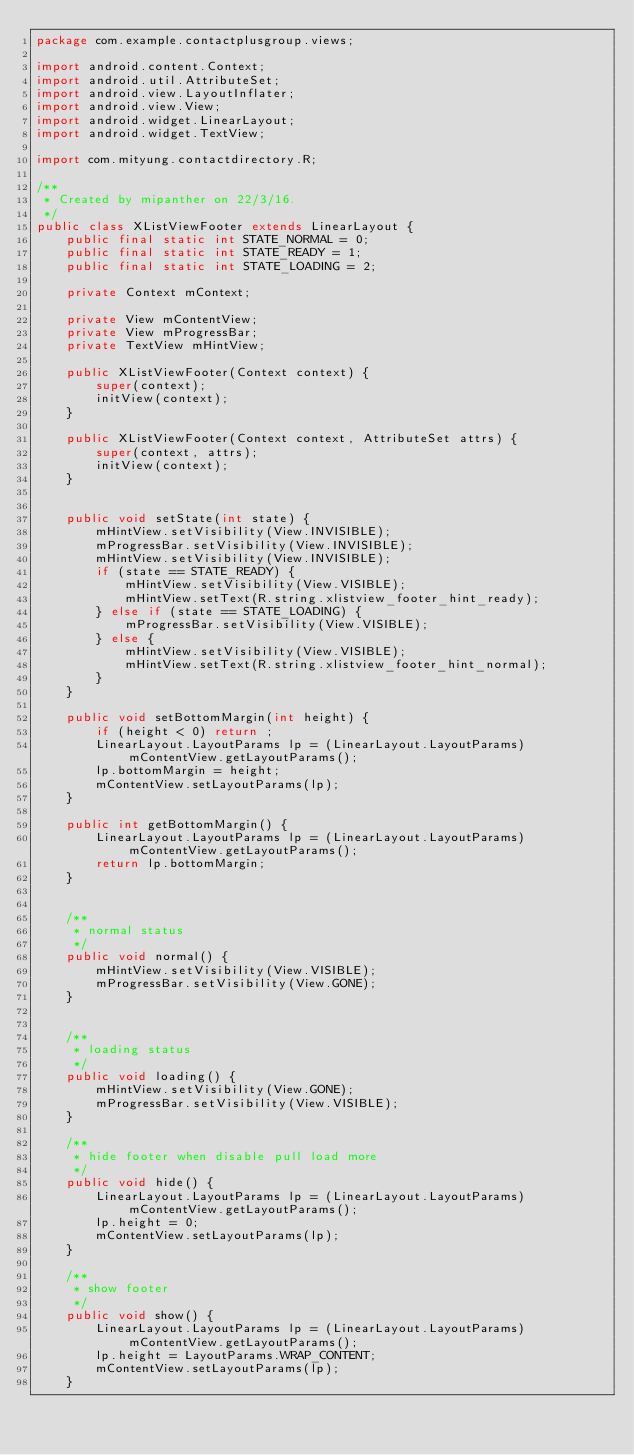<code> <loc_0><loc_0><loc_500><loc_500><_Java_>package com.example.contactplusgroup.views;

import android.content.Context;
import android.util.AttributeSet;
import android.view.LayoutInflater;
import android.view.View;
import android.widget.LinearLayout;
import android.widget.TextView;

import com.mityung.contactdirectory.R;

/**
 * Created by mipanther on 22/3/16.
 */
public class XListViewFooter extends LinearLayout {
    public final static int STATE_NORMAL = 0;
    public final static int STATE_READY = 1;
    public final static int STATE_LOADING = 2;

    private Context mContext;

    private View mContentView;
    private View mProgressBar;
    private TextView mHintView;

    public XListViewFooter(Context context) {
        super(context);
        initView(context);
    }

    public XListViewFooter(Context context, AttributeSet attrs) {
        super(context, attrs);
        initView(context);
    }


    public void setState(int state) {
        mHintView.setVisibility(View.INVISIBLE);
        mProgressBar.setVisibility(View.INVISIBLE);
        mHintView.setVisibility(View.INVISIBLE);
        if (state == STATE_READY) {
            mHintView.setVisibility(View.VISIBLE);
            mHintView.setText(R.string.xlistview_footer_hint_ready);
        } else if (state == STATE_LOADING) {
            mProgressBar.setVisibility(View.VISIBLE);
        } else {
            mHintView.setVisibility(View.VISIBLE);
            mHintView.setText(R.string.xlistview_footer_hint_normal);
        }
    }

    public void setBottomMargin(int height) {
        if (height < 0) return ;
        LinearLayout.LayoutParams lp = (LinearLayout.LayoutParams)mContentView.getLayoutParams();
        lp.bottomMargin = height;
        mContentView.setLayoutParams(lp);
    }

    public int getBottomMargin() {
        LinearLayout.LayoutParams lp = (LinearLayout.LayoutParams)mContentView.getLayoutParams();
        return lp.bottomMargin;
    }


    /**
     * normal status
     */
    public void normal() {
        mHintView.setVisibility(View.VISIBLE);
        mProgressBar.setVisibility(View.GONE);
    }


    /**
     * loading status
     */
    public void loading() {
        mHintView.setVisibility(View.GONE);
        mProgressBar.setVisibility(View.VISIBLE);
    }

    /**
     * hide footer when disable pull load more
     */
    public void hide() {
        LinearLayout.LayoutParams lp = (LinearLayout.LayoutParams)mContentView.getLayoutParams();
        lp.height = 0;
        mContentView.setLayoutParams(lp);
    }

    /**
     * show footer
     */
    public void show() {
        LinearLayout.LayoutParams lp = (LinearLayout.LayoutParams)mContentView.getLayoutParams();
        lp.height = LayoutParams.WRAP_CONTENT;
        mContentView.setLayoutParams(lp);
    }
</code> 